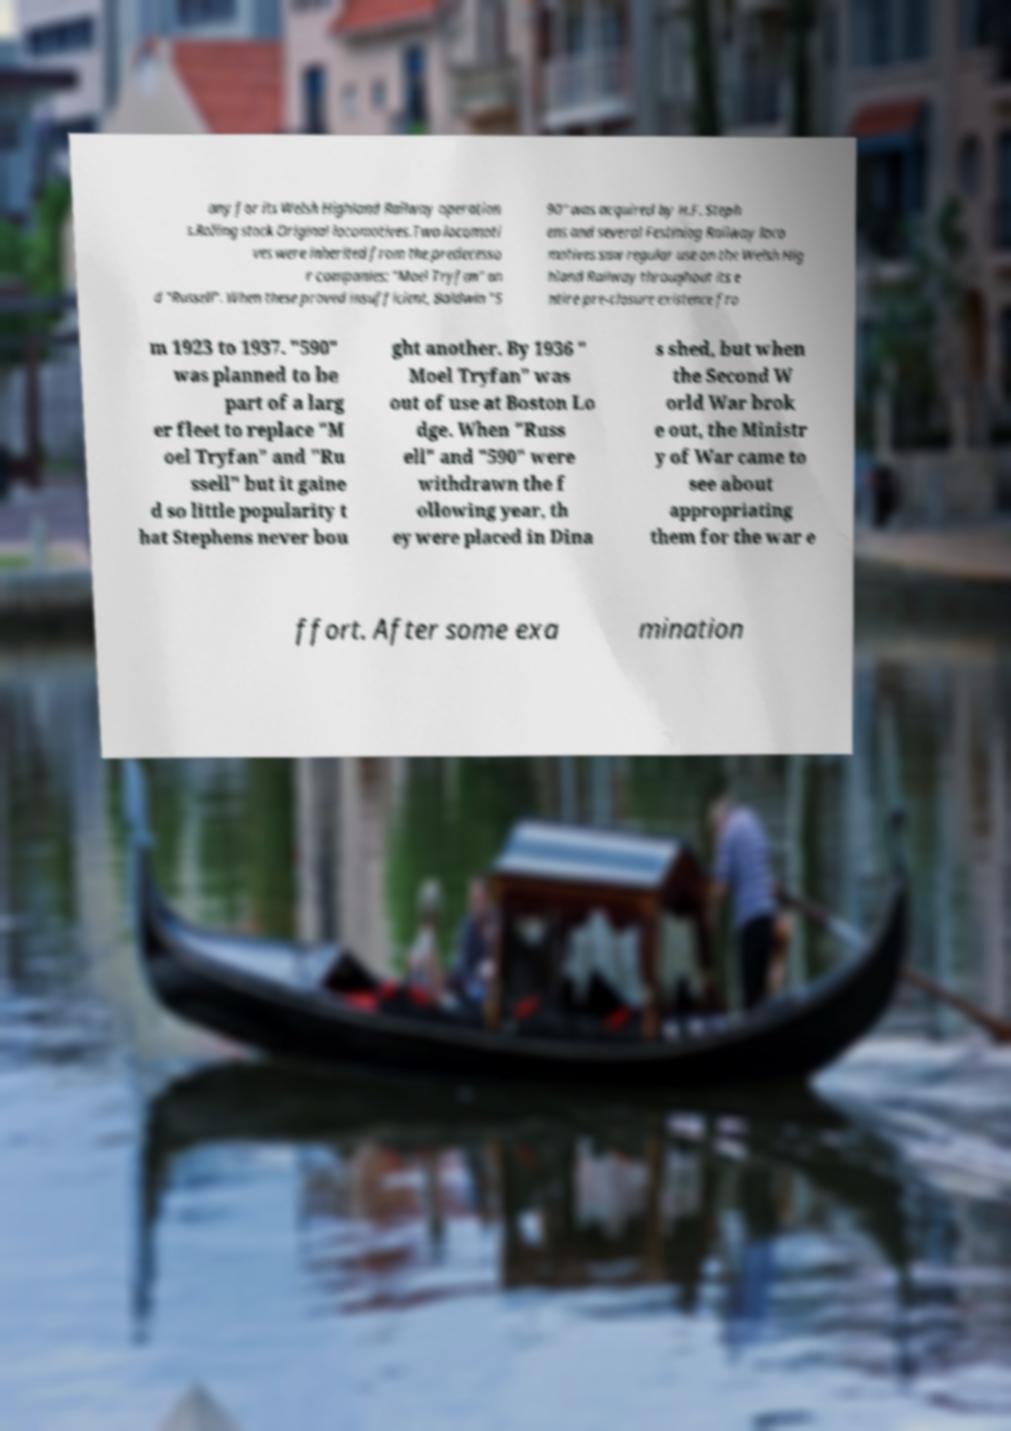For documentation purposes, I need the text within this image transcribed. Could you provide that? any for its Welsh Highland Railway operation s.Rolling stock.Original locomotives.Two locomoti ves were inherited from the predecesso r companies: "Moel Tryfan" an d "Russell". When these proved insufficient, Baldwin "5 90" was acquired by H.F. Steph ens and several Festiniog Railway loco motives saw regular use on the Welsh Hig hland Railway throughout its e ntire pre-closure existence fro m 1923 to 1937. "590" was planned to be part of a larg er fleet to replace "M oel Tryfan" and "Ru ssell" but it gaine d so little popularity t hat Stephens never bou ght another. By 1936 " Moel Tryfan" was out of use at Boston Lo dge. When "Russ ell" and "590" were withdrawn the f ollowing year, th ey were placed in Dina s shed, but when the Second W orld War brok e out, the Ministr y of War came to see about appropriating them for the war e ffort. After some exa mination 